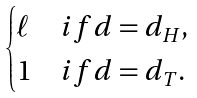Convert formula to latex. <formula><loc_0><loc_0><loc_500><loc_500>\begin{cases} \ell & i f d = d _ { H } , \\ 1 & i f d = d _ { T } . \end{cases}</formula> 